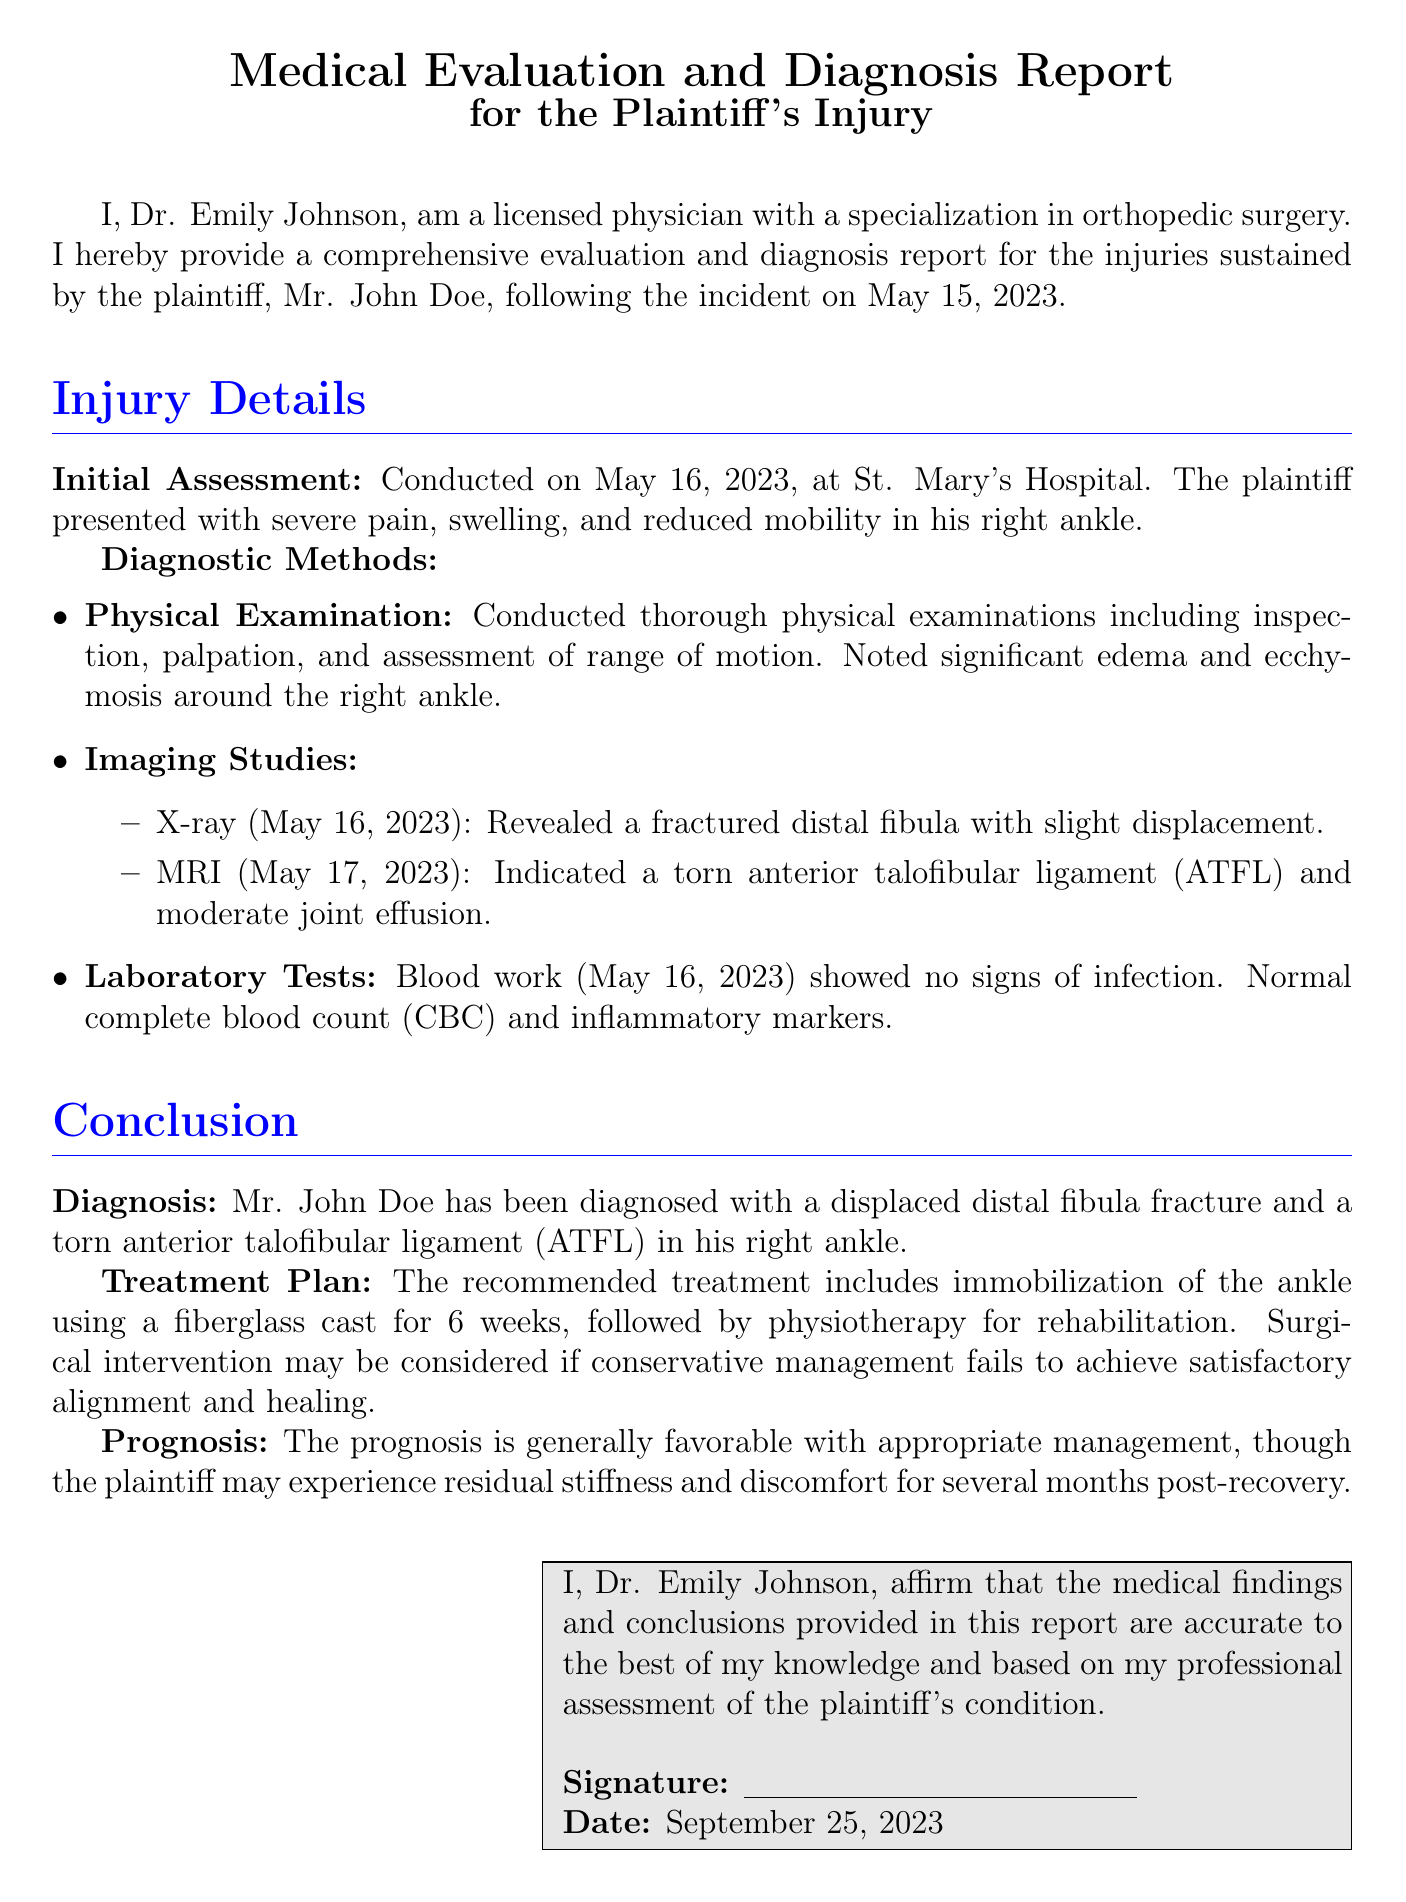What is the name of the plaintiff? The plaintiff is referred to as Mr. John Doe in the document.
Answer: Mr. John Doe When did the initial assessment take place? The initial assessment took place the day after the incident, on May 16, 2023.
Answer: May 16, 2023 What type of fracture was diagnosed? The diagnosis indicates a specific type of injury to the ankle.
Answer: Distal fibula fracture What imaging study was performed on May 17, 2023? The document states that an MRI was conducted the day after the initial X-ray.
Answer: MRI What is the treatment plan duration mentioned for immobilization? The document specifies how long the plaintiff should wear the cast for proper healing.
Answer: 6 weeks Which ligament was indicated as torn in the MRI? The MRI results highlighted a specific injury to a ligament in the ankle.
Answer: Anterior talofibular ligament (ATFL) What is the overall prognosis following treatment? The prognosis section describes the expected outcome of the plaintiff's condition.
Answer: Generally favorable Who signed the medical evaluation report? The document concludes with the name of the physician who performed the evaluation.
Answer: Dr. Emily Johnson 